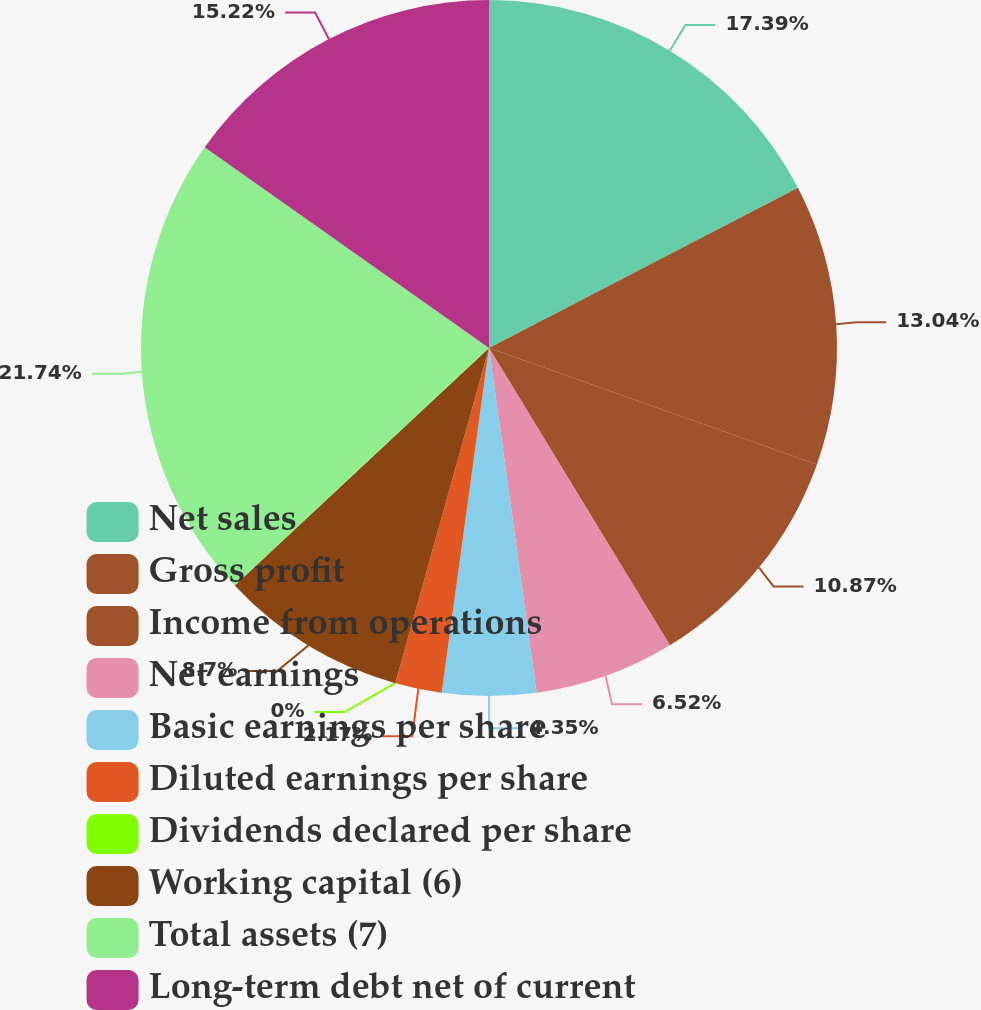Convert chart. <chart><loc_0><loc_0><loc_500><loc_500><pie_chart><fcel>Net sales<fcel>Gross profit<fcel>Income from operations<fcel>Net earnings<fcel>Basic earnings per share<fcel>Diluted earnings per share<fcel>Dividends declared per share<fcel>Working capital (6)<fcel>Total assets (7)<fcel>Long-term debt net of current<nl><fcel>17.39%<fcel>13.04%<fcel>10.87%<fcel>6.52%<fcel>4.35%<fcel>2.17%<fcel>0.0%<fcel>8.7%<fcel>21.74%<fcel>15.22%<nl></chart> 